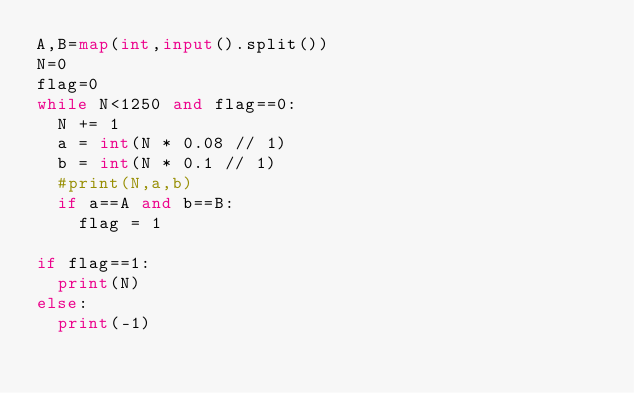Convert code to text. <code><loc_0><loc_0><loc_500><loc_500><_Python_>A,B=map(int,input().split())
N=0
flag=0
while N<1250 and flag==0:
  N += 1
  a = int(N * 0.08 // 1)
  b = int(N * 0.1 // 1)
  #print(N,a,b)
  if a==A and b==B:
    flag = 1
    
if flag==1:
  print(N)
else:
  print(-1)</code> 